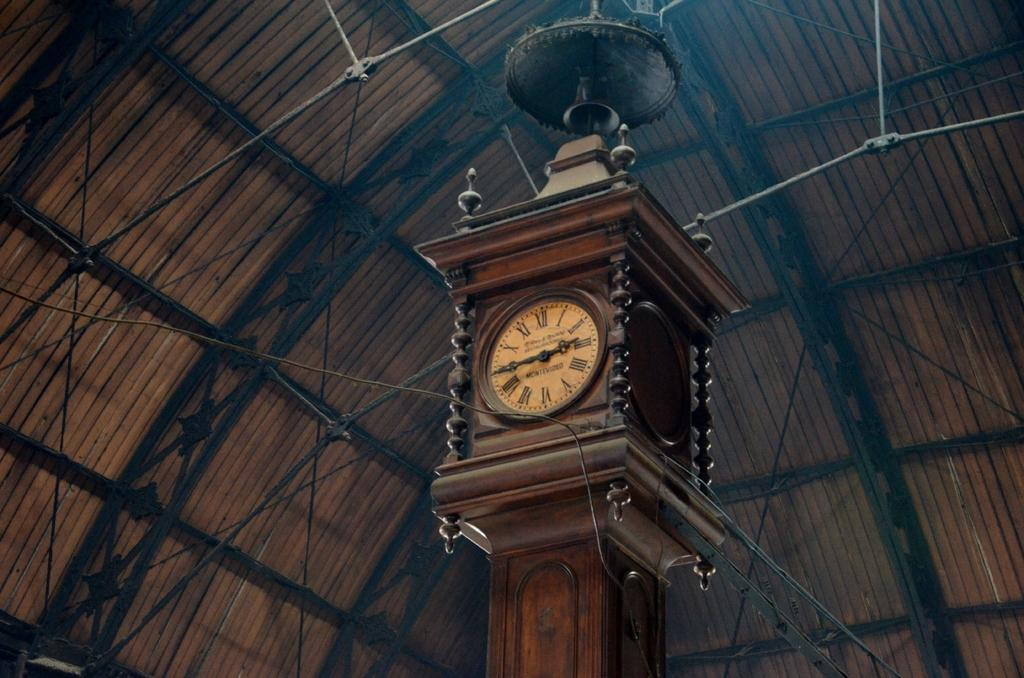<image>
Describe the image concisely. A clock in an old building says Montevideo on the face. 